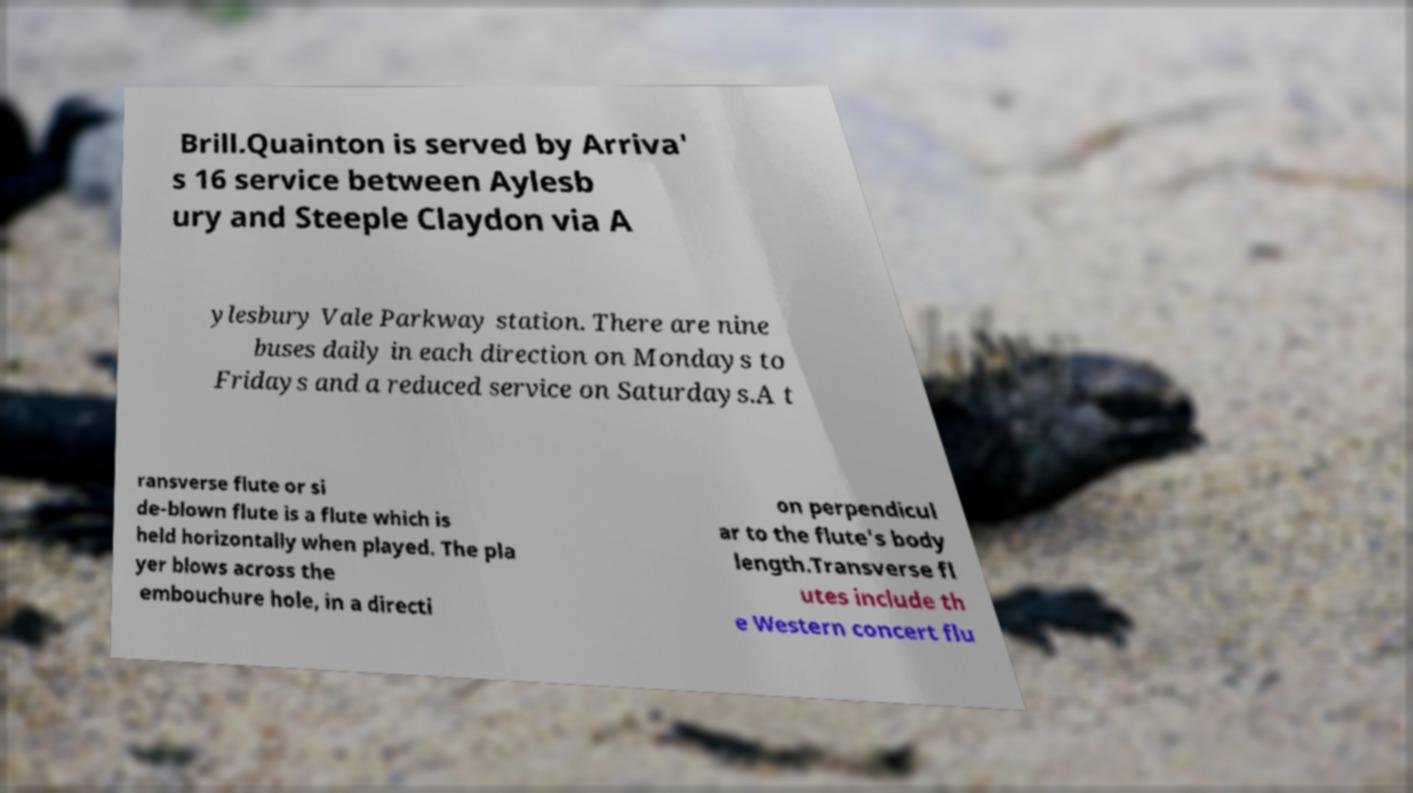Could you extract and type out the text from this image? Brill.Quainton is served by Arriva' s 16 service between Aylesb ury and Steeple Claydon via A ylesbury Vale Parkway station. There are nine buses daily in each direction on Mondays to Fridays and a reduced service on Saturdays.A t ransverse flute or si de-blown flute is a flute which is held horizontally when played. The pla yer blows across the embouchure hole, in a directi on perpendicul ar to the flute's body length.Transverse fl utes include th e Western concert flu 